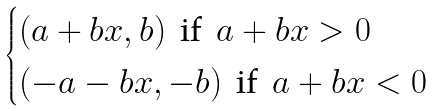<formula> <loc_0><loc_0><loc_500><loc_500>\begin{cases} ( a + b x , b ) \, \text { if } \, a + b x > 0 \\ ( - a - b x , - b ) \, \text { if } \, a + b x < 0 \end{cases}</formula> 